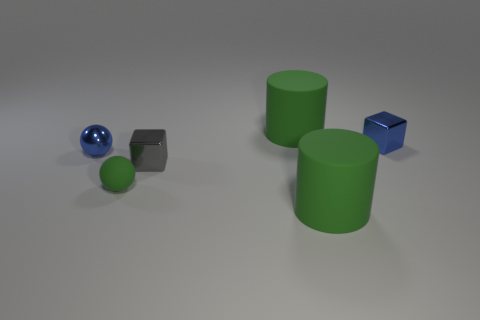What number of things are either green things in front of the gray metal object or large cyan matte cylinders?
Make the answer very short. 2. Are there more small blue objects that are left of the tiny green sphere than green rubber cylinders that are to the left of the gray block?
Offer a terse response. Yes. How many rubber objects are gray things or tiny blue blocks?
Provide a succinct answer. 0. Are there fewer matte things on the left side of the small blue shiny ball than objects that are on the right side of the gray metal object?
Give a very brief answer. Yes. How many things are blue metal blocks or big green things that are in front of the tiny matte object?
Ensure brevity in your answer.  2. What is the material of the block that is the same size as the gray thing?
Offer a terse response. Metal. Is the material of the green ball the same as the gray object?
Offer a terse response. No. There is a tiny thing that is in front of the blue metal sphere and behind the tiny green rubber thing; what color is it?
Offer a very short reply. Gray. Do the cylinder in front of the green sphere and the small rubber thing have the same color?
Make the answer very short. Yes. There is a green rubber thing that is the same size as the gray object; what is its shape?
Give a very brief answer. Sphere. 